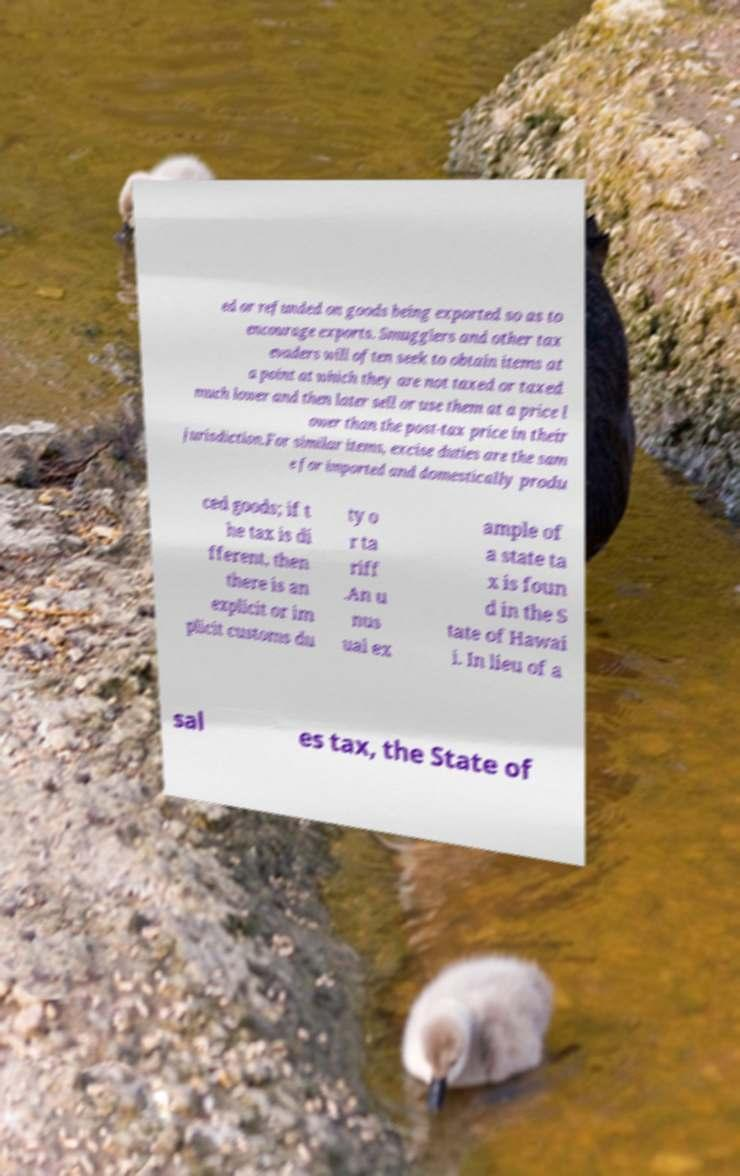Please read and relay the text visible in this image. What does it say? ed or refunded on goods being exported so as to encourage exports. Smugglers and other tax evaders will often seek to obtain items at a point at which they are not taxed or taxed much lower and then later sell or use them at a price l ower than the post-tax price in their jurisdiction.For similar items, excise duties are the sam e for imported and domestically produ ced goods; if t he tax is di fferent, then there is an explicit or im plicit customs du ty o r ta riff .An u nus ual ex ample of a state ta x is foun d in the S tate of Hawai i. In lieu of a sal es tax, the State of 